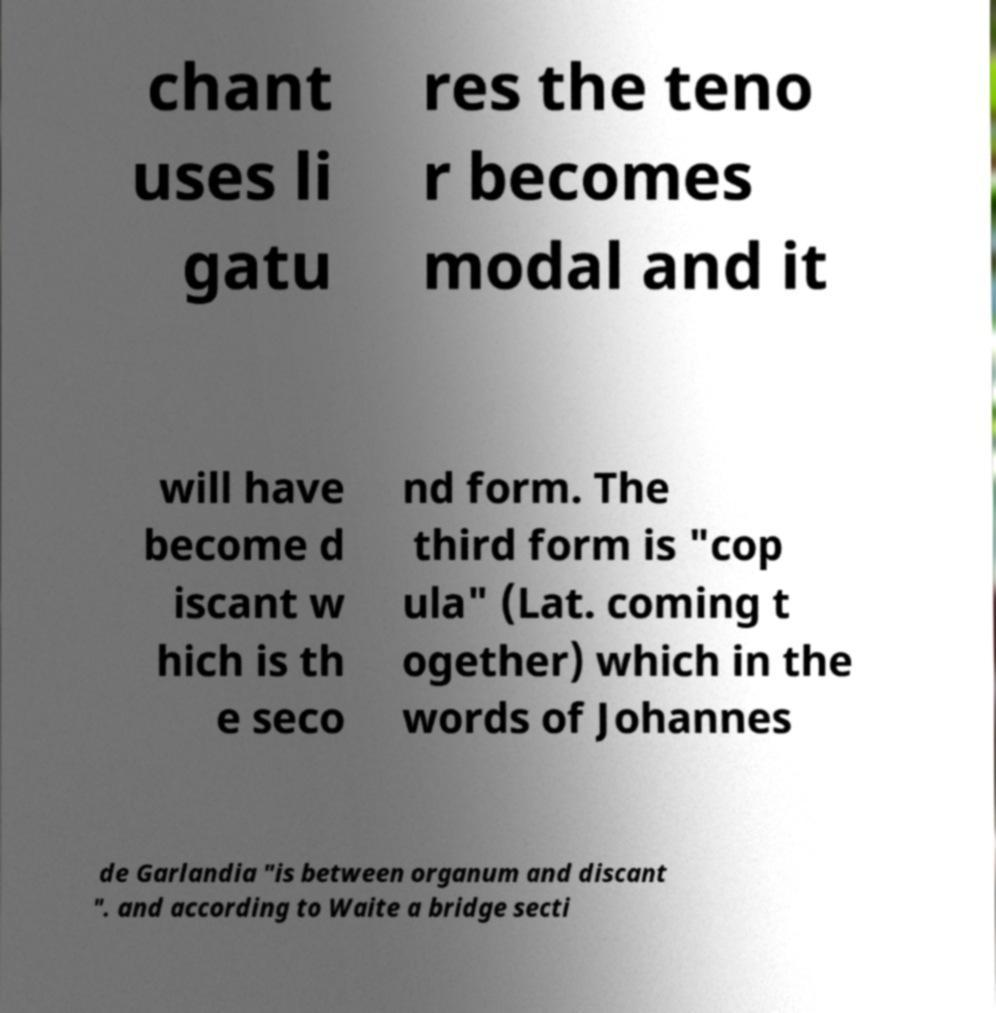Can you read and provide the text displayed in the image?This photo seems to have some interesting text. Can you extract and type it out for me? chant uses li gatu res the teno r becomes modal and it will have become d iscant w hich is th e seco nd form. The third form is "cop ula" (Lat. coming t ogether) which in the words of Johannes de Garlandia "is between organum and discant ". and according to Waite a bridge secti 